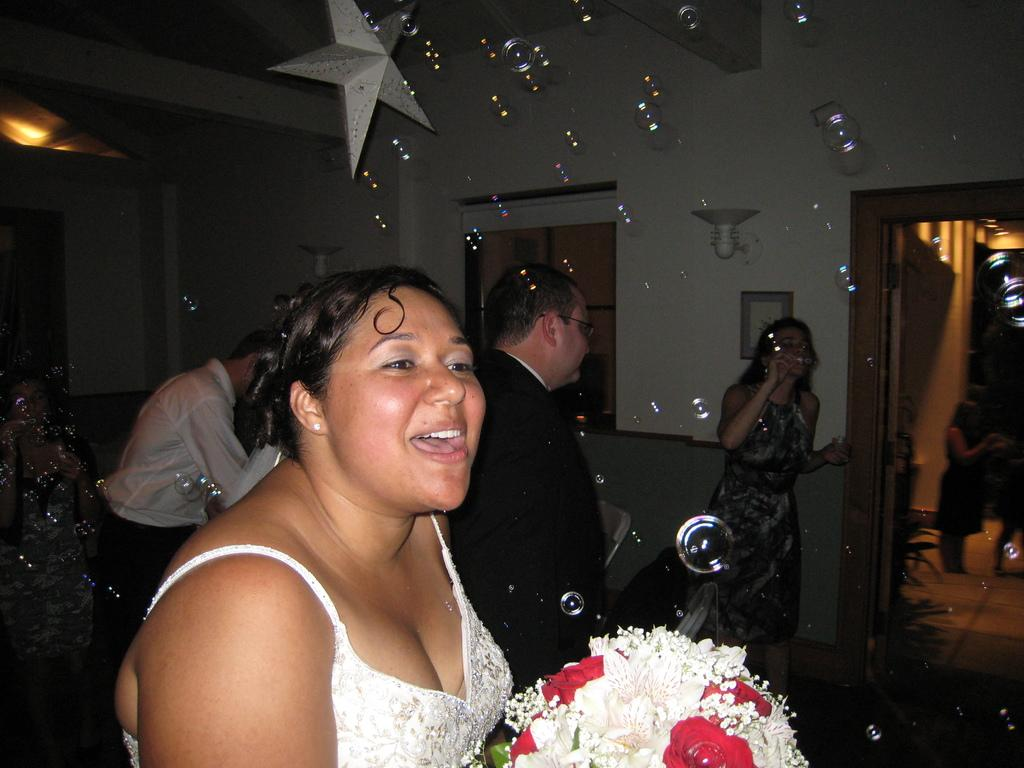What is the main subject of the image? There is a group of people standing in the image. Are there any objects or items visible in the image? Yes, there is a flower bouquet and chairs in the image. Can you describe the background of the image? There are walls visible in the background of the image. What other objects might be present in the image? There are other objects in the image, but their specific details are not mentioned in the provided facts. How many pigs are visible in the image? There are no pigs present in the image. What year is depicted in the image? The provided facts do not mention any specific year or time period, so it cannot be determined from the image. 